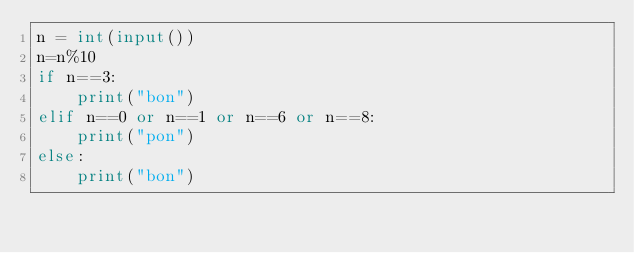Convert code to text. <code><loc_0><loc_0><loc_500><loc_500><_Python_>n = int(input())
n=n%10
if n==3:
    print("bon")
elif n==0 or n==1 or n==6 or n==8:
    print("pon")
else:
    print("bon")</code> 